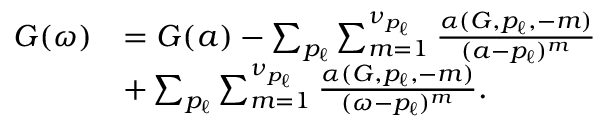Convert formula to latex. <formula><loc_0><loc_0><loc_500><loc_500>\begin{array} { r } { \begin{array} { r l } { G ( \omega ) } & { = G ( a ) - \sum _ { p _ { \ell } } \sum _ { m = 1 } ^ { \nu _ { p _ { \ell } } } \frac { \alpha ( G , p _ { \ell } , - m ) } { ( a - p _ { \ell } ) ^ { m } } } \\ & { + \sum _ { p _ { \ell } } \sum _ { m = 1 } ^ { \nu _ { p _ { \ell } } } \frac { \alpha ( G , p _ { \ell } , - m ) } { ( \omega - p _ { \ell } ) ^ { m } } . } \end{array} } \end{array}</formula> 